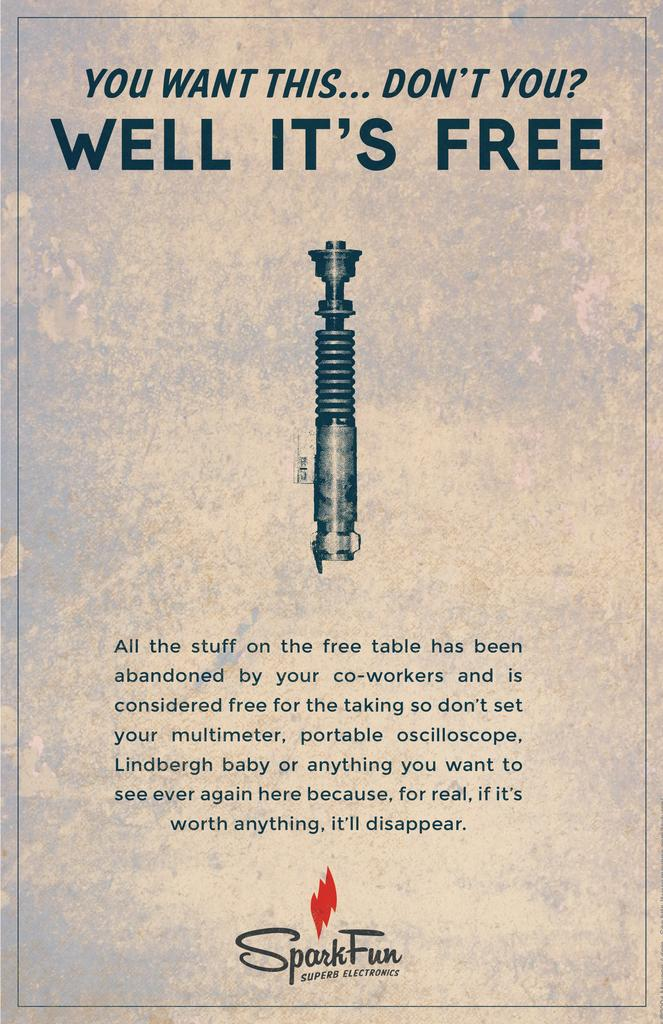Provide a one-sentence caption for the provided image. An advertisement for Spark Fun Super Electronics describes a free promotion. 